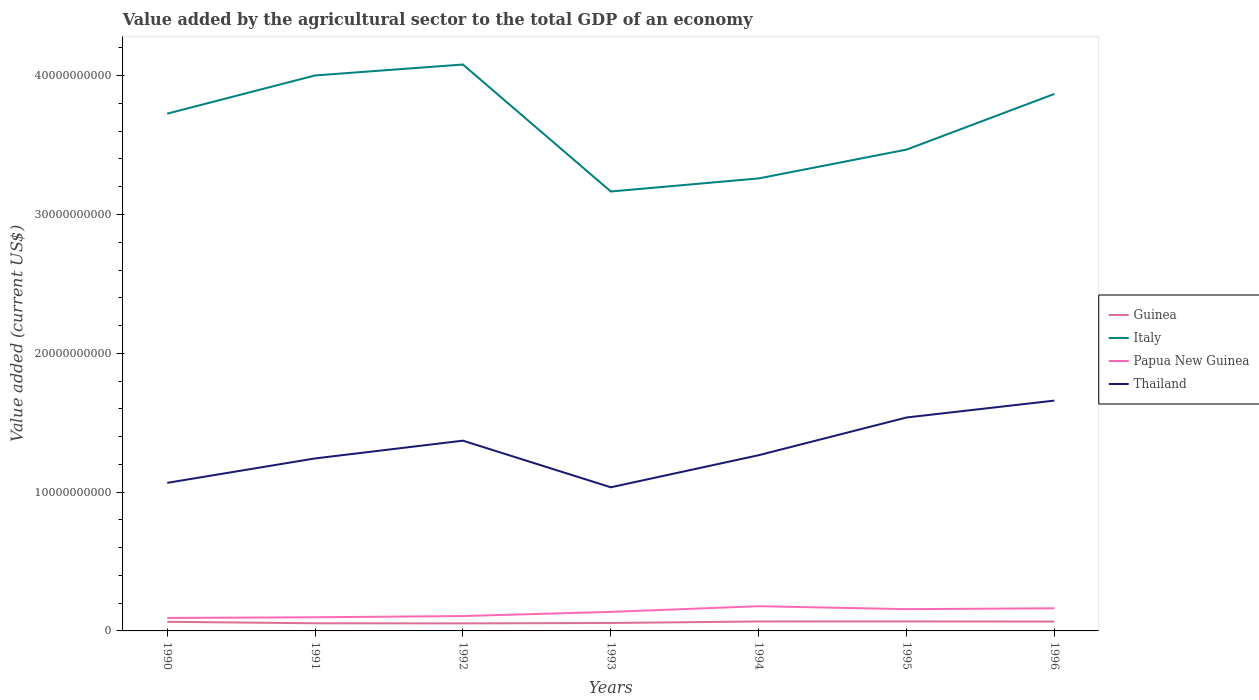How many different coloured lines are there?
Make the answer very short. 4. Does the line corresponding to Italy intersect with the line corresponding to Thailand?
Keep it short and to the point. No. Across all years, what is the maximum value added by the agricultural sector to the total GDP in Italy?
Your answer should be compact. 3.17e+1. In which year was the value added by the agricultural sector to the total GDP in Papua New Guinea maximum?
Your response must be concise. 1990. What is the total value added by the agricultural sector to the total GDP in Papua New Guinea in the graph?
Give a very brief answer. -2.60e+08. What is the difference between the highest and the second highest value added by the agricultural sector to the total GDP in Papua New Guinea?
Your response must be concise. 8.48e+08. Is the value added by the agricultural sector to the total GDP in Thailand strictly greater than the value added by the agricultural sector to the total GDP in Guinea over the years?
Ensure brevity in your answer.  No. How many lines are there?
Give a very brief answer. 4. How many years are there in the graph?
Your response must be concise. 7. What is the difference between two consecutive major ticks on the Y-axis?
Offer a terse response. 1.00e+1. Are the values on the major ticks of Y-axis written in scientific E-notation?
Keep it short and to the point. No. Where does the legend appear in the graph?
Make the answer very short. Center right. How many legend labels are there?
Make the answer very short. 4. What is the title of the graph?
Offer a very short reply. Value added by the agricultural sector to the total GDP of an economy. What is the label or title of the X-axis?
Offer a very short reply. Years. What is the label or title of the Y-axis?
Give a very brief answer. Value added (current US$). What is the Value added (current US$) of Guinea in 1990?
Offer a terse response. 6.58e+08. What is the Value added (current US$) in Italy in 1990?
Give a very brief answer. 3.73e+1. What is the Value added (current US$) of Papua New Guinea in 1990?
Provide a short and direct response. 9.33e+08. What is the Value added (current US$) in Thailand in 1990?
Provide a succinct answer. 1.07e+1. What is the Value added (current US$) of Guinea in 1991?
Provide a short and direct response. 5.51e+08. What is the Value added (current US$) in Italy in 1991?
Provide a succinct answer. 4.00e+1. What is the Value added (current US$) of Papua New Guinea in 1991?
Offer a very short reply. 9.84e+08. What is the Value added (current US$) of Thailand in 1991?
Your answer should be very brief. 1.24e+1. What is the Value added (current US$) in Guinea in 1992?
Provide a short and direct response. 5.44e+08. What is the Value added (current US$) in Italy in 1992?
Your answer should be compact. 4.08e+1. What is the Value added (current US$) of Papua New Guinea in 1992?
Your answer should be very brief. 1.07e+09. What is the Value added (current US$) in Thailand in 1992?
Offer a very short reply. 1.37e+1. What is the Value added (current US$) in Guinea in 1993?
Ensure brevity in your answer.  5.70e+08. What is the Value added (current US$) in Italy in 1993?
Provide a short and direct response. 3.17e+1. What is the Value added (current US$) in Papua New Guinea in 1993?
Give a very brief answer. 1.37e+09. What is the Value added (current US$) of Thailand in 1993?
Provide a short and direct response. 1.03e+1. What is the Value added (current US$) in Guinea in 1994?
Keep it short and to the point. 6.82e+08. What is the Value added (current US$) in Italy in 1994?
Offer a terse response. 3.26e+1. What is the Value added (current US$) in Papua New Guinea in 1994?
Your response must be concise. 1.78e+09. What is the Value added (current US$) in Thailand in 1994?
Keep it short and to the point. 1.27e+1. What is the Value added (current US$) in Guinea in 1995?
Provide a succinct answer. 6.84e+08. What is the Value added (current US$) in Italy in 1995?
Your response must be concise. 3.47e+1. What is the Value added (current US$) of Papua New Guinea in 1995?
Offer a terse response. 1.57e+09. What is the Value added (current US$) of Thailand in 1995?
Provide a succinct answer. 1.54e+1. What is the Value added (current US$) of Guinea in 1996?
Your answer should be very brief. 6.73e+08. What is the Value added (current US$) in Italy in 1996?
Make the answer very short. 3.87e+1. What is the Value added (current US$) in Papua New Guinea in 1996?
Your response must be concise. 1.63e+09. What is the Value added (current US$) in Thailand in 1996?
Make the answer very short. 1.66e+1. Across all years, what is the maximum Value added (current US$) in Guinea?
Provide a short and direct response. 6.84e+08. Across all years, what is the maximum Value added (current US$) in Italy?
Your answer should be compact. 4.08e+1. Across all years, what is the maximum Value added (current US$) of Papua New Guinea?
Make the answer very short. 1.78e+09. Across all years, what is the maximum Value added (current US$) in Thailand?
Provide a succinct answer. 1.66e+1. Across all years, what is the minimum Value added (current US$) in Guinea?
Offer a terse response. 5.44e+08. Across all years, what is the minimum Value added (current US$) of Italy?
Offer a terse response. 3.17e+1. Across all years, what is the minimum Value added (current US$) of Papua New Guinea?
Provide a succinct answer. 9.33e+08. Across all years, what is the minimum Value added (current US$) in Thailand?
Keep it short and to the point. 1.03e+1. What is the total Value added (current US$) of Guinea in the graph?
Make the answer very short. 4.36e+09. What is the total Value added (current US$) of Italy in the graph?
Your answer should be very brief. 2.56e+11. What is the total Value added (current US$) in Papua New Guinea in the graph?
Your answer should be compact. 9.34e+09. What is the total Value added (current US$) of Thailand in the graph?
Your answer should be compact. 9.18e+1. What is the difference between the Value added (current US$) in Guinea in 1990 and that in 1991?
Your response must be concise. 1.08e+08. What is the difference between the Value added (current US$) of Italy in 1990 and that in 1991?
Your answer should be compact. -2.75e+09. What is the difference between the Value added (current US$) in Papua New Guinea in 1990 and that in 1991?
Provide a succinct answer. -5.10e+07. What is the difference between the Value added (current US$) in Thailand in 1990 and that in 1991?
Your answer should be compact. -1.76e+09. What is the difference between the Value added (current US$) of Guinea in 1990 and that in 1992?
Your response must be concise. 1.15e+08. What is the difference between the Value added (current US$) of Italy in 1990 and that in 1992?
Give a very brief answer. -3.54e+09. What is the difference between the Value added (current US$) of Papua New Guinea in 1990 and that in 1992?
Keep it short and to the point. -1.39e+08. What is the difference between the Value added (current US$) of Thailand in 1990 and that in 1992?
Keep it short and to the point. -3.04e+09. What is the difference between the Value added (current US$) in Guinea in 1990 and that in 1993?
Your answer should be very brief. 8.80e+07. What is the difference between the Value added (current US$) in Italy in 1990 and that in 1993?
Your response must be concise. 5.61e+09. What is the difference between the Value added (current US$) of Papua New Guinea in 1990 and that in 1993?
Give a very brief answer. -4.38e+08. What is the difference between the Value added (current US$) of Thailand in 1990 and that in 1993?
Provide a succinct answer. 3.20e+08. What is the difference between the Value added (current US$) of Guinea in 1990 and that in 1994?
Make the answer very short. -2.40e+07. What is the difference between the Value added (current US$) of Italy in 1990 and that in 1994?
Ensure brevity in your answer.  4.67e+09. What is the difference between the Value added (current US$) in Papua New Guinea in 1990 and that in 1994?
Provide a succinct answer. -8.48e+08. What is the difference between the Value added (current US$) of Thailand in 1990 and that in 1994?
Offer a very short reply. -1.99e+09. What is the difference between the Value added (current US$) in Guinea in 1990 and that in 1995?
Provide a succinct answer. -2.57e+07. What is the difference between the Value added (current US$) in Italy in 1990 and that in 1995?
Your answer should be very brief. 2.59e+09. What is the difference between the Value added (current US$) in Papua New Guinea in 1990 and that in 1995?
Offer a very short reply. -6.35e+08. What is the difference between the Value added (current US$) of Thailand in 1990 and that in 1995?
Make the answer very short. -4.71e+09. What is the difference between the Value added (current US$) in Guinea in 1990 and that in 1996?
Give a very brief answer. -1.48e+07. What is the difference between the Value added (current US$) in Italy in 1990 and that in 1996?
Make the answer very short. -1.42e+09. What is the difference between the Value added (current US$) of Papua New Guinea in 1990 and that in 1996?
Your answer should be very brief. -6.99e+08. What is the difference between the Value added (current US$) in Thailand in 1990 and that in 1996?
Keep it short and to the point. -5.92e+09. What is the difference between the Value added (current US$) of Guinea in 1991 and that in 1992?
Offer a terse response. 6.75e+06. What is the difference between the Value added (current US$) in Italy in 1991 and that in 1992?
Provide a short and direct response. -7.87e+08. What is the difference between the Value added (current US$) in Papua New Guinea in 1991 and that in 1992?
Your response must be concise. -8.75e+07. What is the difference between the Value added (current US$) of Thailand in 1991 and that in 1992?
Your answer should be compact. -1.28e+09. What is the difference between the Value added (current US$) in Guinea in 1991 and that in 1993?
Offer a terse response. -1.98e+07. What is the difference between the Value added (current US$) of Italy in 1991 and that in 1993?
Give a very brief answer. 8.36e+09. What is the difference between the Value added (current US$) in Papua New Guinea in 1991 and that in 1993?
Your answer should be very brief. -3.87e+08. What is the difference between the Value added (current US$) in Thailand in 1991 and that in 1993?
Provide a succinct answer. 2.08e+09. What is the difference between the Value added (current US$) of Guinea in 1991 and that in 1994?
Your answer should be compact. -1.32e+08. What is the difference between the Value added (current US$) in Italy in 1991 and that in 1994?
Your answer should be compact. 7.42e+09. What is the difference between the Value added (current US$) of Papua New Guinea in 1991 and that in 1994?
Offer a terse response. -7.97e+08. What is the difference between the Value added (current US$) in Thailand in 1991 and that in 1994?
Offer a very short reply. -2.31e+08. What is the difference between the Value added (current US$) in Guinea in 1991 and that in 1995?
Give a very brief answer. -1.33e+08. What is the difference between the Value added (current US$) in Italy in 1991 and that in 1995?
Your answer should be compact. 5.34e+09. What is the difference between the Value added (current US$) in Papua New Guinea in 1991 and that in 1995?
Offer a very short reply. -5.84e+08. What is the difference between the Value added (current US$) in Thailand in 1991 and that in 1995?
Ensure brevity in your answer.  -2.95e+09. What is the difference between the Value added (current US$) of Guinea in 1991 and that in 1996?
Provide a succinct answer. -1.23e+08. What is the difference between the Value added (current US$) in Italy in 1991 and that in 1996?
Provide a short and direct response. 1.33e+09. What is the difference between the Value added (current US$) of Papua New Guinea in 1991 and that in 1996?
Give a very brief answer. -6.48e+08. What is the difference between the Value added (current US$) in Thailand in 1991 and that in 1996?
Ensure brevity in your answer.  -4.17e+09. What is the difference between the Value added (current US$) of Guinea in 1992 and that in 1993?
Ensure brevity in your answer.  -2.66e+07. What is the difference between the Value added (current US$) in Italy in 1992 and that in 1993?
Make the answer very short. 9.15e+09. What is the difference between the Value added (current US$) of Papua New Guinea in 1992 and that in 1993?
Provide a succinct answer. -3.00e+08. What is the difference between the Value added (current US$) in Thailand in 1992 and that in 1993?
Offer a very short reply. 3.36e+09. What is the difference between the Value added (current US$) in Guinea in 1992 and that in 1994?
Your response must be concise. -1.39e+08. What is the difference between the Value added (current US$) of Italy in 1992 and that in 1994?
Ensure brevity in your answer.  8.21e+09. What is the difference between the Value added (current US$) in Papua New Guinea in 1992 and that in 1994?
Your answer should be very brief. -7.09e+08. What is the difference between the Value added (current US$) of Thailand in 1992 and that in 1994?
Offer a terse response. 1.05e+09. What is the difference between the Value added (current US$) of Guinea in 1992 and that in 1995?
Give a very brief answer. -1.40e+08. What is the difference between the Value added (current US$) in Italy in 1992 and that in 1995?
Provide a succinct answer. 6.13e+09. What is the difference between the Value added (current US$) of Papua New Guinea in 1992 and that in 1995?
Ensure brevity in your answer.  -4.96e+08. What is the difference between the Value added (current US$) in Thailand in 1992 and that in 1995?
Give a very brief answer. -1.67e+09. What is the difference between the Value added (current US$) of Guinea in 1992 and that in 1996?
Offer a terse response. -1.29e+08. What is the difference between the Value added (current US$) in Italy in 1992 and that in 1996?
Offer a very short reply. 2.12e+09. What is the difference between the Value added (current US$) of Papua New Guinea in 1992 and that in 1996?
Offer a terse response. -5.60e+08. What is the difference between the Value added (current US$) in Thailand in 1992 and that in 1996?
Give a very brief answer. -2.89e+09. What is the difference between the Value added (current US$) in Guinea in 1993 and that in 1994?
Keep it short and to the point. -1.12e+08. What is the difference between the Value added (current US$) in Italy in 1993 and that in 1994?
Offer a very short reply. -9.42e+08. What is the difference between the Value added (current US$) in Papua New Guinea in 1993 and that in 1994?
Give a very brief answer. -4.09e+08. What is the difference between the Value added (current US$) in Thailand in 1993 and that in 1994?
Ensure brevity in your answer.  -2.31e+09. What is the difference between the Value added (current US$) in Guinea in 1993 and that in 1995?
Offer a terse response. -1.14e+08. What is the difference between the Value added (current US$) of Italy in 1993 and that in 1995?
Give a very brief answer. -3.02e+09. What is the difference between the Value added (current US$) of Papua New Guinea in 1993 and that in 1995?
Make the answer very short. -1.96e+08. What is the difference between the Value added (current US$) in Thailand in 1993 and that in 1995?
Give a very brief answer. -5.03e+09. What is the difference between the Value added (current US$) of Guinea in 1993 and that in 1996?
Your answer should be very brief. -1.03e+08. What is the difference between the Value added (current US$) of Italy in 1993 and that in 1996?
Your response must be concise. -7.03e+09. What is the difference between the Value added (current US$) in Papua New Guinea in 1993 and that in 1996?
Your answer should be compact. -2.60e+08. What is the difference between the Value added (current US$) of Thailand in 1993 and that in 1996?
Keep it short and to the point. -6.25e+09. What is the difference between the Value added (current US$) in Guinea in 1994 and that in 1995?
Ensure brevity in your answer.  -1.69e+06. What is the difference between the Value added (current US$) of Italy in 1994 and that in 1995?
Ensure brevity in your answer.  -2.08e+09. What is the difference between the Value added (current US$) of Papua New Guinea in 1994 and that in 1995?
Give a very brief answer. 2.13e+08. What is the difference between the Value added (current US$) of Thailand in 1994 and that in 1995?
Offer a very short reply. -2.72e+09. What is the difference between the Value added (current US$) of Guinea in 1994 and that in 1996?
Your answer should be very brief. 9.15e+06. What is the difference between the Value added (current US$) in Italy in 1994 and that in 1996?
Offer a terse response. -6.09e+09. What is the difference between the Value added (current US$) of Papua New Guinea in 1994 and that in 1996?
Provide a succinct answer. 1.49e+08. What is the difference between the Value added (current US$) of Thailand in 1994 and that in 1996?
Your answer should be compact. -3.93e+09. What is the difference between the Value added (current US$) of Guinea in 1995 and that in 1996?
Offer a terse response. 1.08e+07. What is the difference between the Value added (current US$) of Italy in 1995 and that in 1996?
Offer a terse response. -4.01e+09. What is the difference between the Value added (current US$) in Papua New Guinea in 1995 and that in 1996?
Your response must be concise. -6.39e+07. What is the difference between the Value added (current US$) in Thailand in 1995 and that in 1996?
Offer a very short reply. -1.22e+09. What is the difference between the Value added (current US$) of Guinea in 1990 and the Value added (current US$) of Italy in 1991?
Your answer should be compact. -3.94e+1. What is the difference between the Value added (current US$) in Guinea in 1990 and the Value added (current US$) in Papua New Guinea in 1991?
Give a very brief answer. -3.26e+08. What is the difference between the Value added (current US$) of Guinea in 1990 and the Value added (current US$) of Thailand in 1991?
Provide a succinct answer. -1.18e+1. What is the difference between the Value added (current US$) in Italy in 1990 and the Value added (current US$) in Papua New Guinea in 1991?
Give a very brief answer. 3.63e+1. What is the difference between the Value added (current US$) in Italy in 1990 and the Value added (current US$) in Thailand in 1991?
Your answer should be very brief. 2.48e+1. What is the difference between the Value added (current US$) in Papua New Guinea in 1990 and the Value added (current US$) in Thailand in 1991?
Give a very brief answer. -1.15e+1. What is the difference between the Value added (current US$) in Guinea in 1990 and the Value added (current US$) in Italy in 1992?
Ensure brevity in your answer.  -4.01e+1. What is the difference between the Value added (current US$) of Guinea in 1990 and the Value added (current US$) of Papua New Guinea in 1992?
Your response must be concise. -4.13e+08. What is the difference between the Value added (current US$) of Guinea in 1990 and the Value added (current US$) of Thailand in 1992?
Provide a short and direct response. -1.30e+1. What is the difference between the Value added (current US$) in Italy in 1990 and the Value added (current US$) in Papua New Guinea in 1992?
Provide a short and direct response. 3.62e+1. What is the difference between the Value added (current US$) in Italy in 1990 and the Value added (current US$) in Thailand in 1992?
Give a very brief answer. 2.36e+1. What is the difference between the Value added (current US$) in Papua New Guinea in 1990 and the Value added (current US$) in Thailand in 1992?
Your answer should be very brief. -1.28e+1. What is the difference between the Value added (current US$) in Guinea in 1990 and the Value added (current US$) in Italy in 1993?
Keep it short and to the point. -3.10e+1. What is the difference between the Value added (current US$) in Guinea in 1990 and the Value added (current US$) in Papua New Guinea in 1993?
Your answer should be very brief. -7.13e+08. What is the difference between the Value added (current US$) of Guinea in 1990 and the Value added (current US$) of Thailand in 1993?
Your response must be concise. -9.69e+09. What is the difference between the Value added (current US$) of Italy in 1990 and the Value added (current US$) of Papua New Guinea in 1993?
Give a very brief answer. 3.59e+1. What is the difference between the Value added (current US$) of Italy in 1990 and the Value added (current US$) of Thailand in 1993?
Your answer should be compact. 2.69e+1. What is the difference between the Value added (current US$) in Papua New Guinea in 1990 and the Value added (current US$) in Thailand in 1993?
Offer a very short reply. -9.41e+09. What is the difference between the Value added (current US$) of Guinea in 1990 and the Value added (current US$) of Italy in 1994?
Your answer should be compact. -3.19e+1. What is the difference between the Value added (current US$) of Guinea in 1990 and the Value added (current US$) of Papua New Guinea in 1994?
Provide a succinct answer. -1.12e+09. What is the difference between the Value added (current US$) of Guinea in 1990 and the Value added (current US$) of Thailand in 1994?
Provide a succinct answer. -1.20e+1. What is the difference between the Value added (current US$) of Italy in 1990 and the Value added (current US$) of Papua New Guinea in 1994?
Your response must be concise. 3.55e+1. What is the difference between the Value added (current US$) in Italy in 1990 and the Value added (current US$) in Thailand in 1994?
Your response must be concise. 2.46e+1. What is the difference between the Value added (current US$) of Papua New Guinea in 1990 and the Value added (current US$) of Thailand in 1994?
Offer a very short reply. -1.17e+1. What is the difference between the Value added (current US$) in Guinea in 1990 and the Value added (current US$) in Italy in 1995?
Give a very brief answer. -3.40e+1. What is the difference between the Value added (current US$) in Guinea in 1990 and the Value added (current US$) in Papua New Guinea in 1995?
Give a very brief answer. -9.09e+08. What is the difference between the Value added (current US$) in Guinea in 1990 and the Value added (current US$) in Thailand in 1995?
Make the answer very short. -1.47e+1. What is the difference between the Value added (current US$) of Italy in 1990 and the Value added (current US$) of Papua New Guinea in 1995?
Offer a very short reply. 3.57e+1. What is the difference between the Value added (current US$) in Italy in 1990 and the Value added (current US$) in Thailand in 1995?
Your answer should be very brief. 2.19e+1. What is the difference between the Value added (current US$) in Papua New Guinea in 1990 and the Value added (current US$) in Thailand in 1995?
Make the answer very short. -1.44e+1. What is the difference between the Value added (current US$) in Guinea in 1990 and the Value added (current US$) in Italy in 1996?
Your answer should be very brief. -3.80e+1. What is the difference between the Value added (current US$) of Guinea in 1990 and the Value added (current US$) of Papua New Guinea in 1996?
Provide a short and direct response. -9.73e+08. What is the difference between the Value added (current US$) in Guinea in 1990 and the Value added (current US$) in Thailand in 1996?
Provide a succinct answer. -1.59e+1. What is the difference between the Value added (current US$) in Italy in 1990 and the Value added (current US$) in Papua New Guinea in 1996?
Your answer should be compact. 3.56e+1. What is the difference between the Value added (current US$) in Italy in 1990 and the Value added (current US$) in Thailand in 1996?
Make the answer very short. 2.07e+1. What is the difference between the Value added (current US$) of Papua New Guinea in 1990 and the Value added (current US$) of Thailand in 1996?
Offer a terse response. -1.57e+1. What is the difference between the Value added (current US$) in Guinea in 1991 and the Value added (current US$) in Italy in 1992?
Provide a succinct answer. -4.03e+1. What is the difference between the Value added (current US$) in Guinea in 1991 and the Value added (current US$) in Papua New Guinea in 1992?
Offer a terse response. -5.21e+08. What is the difference between the Value added (current US$) of Guinea in 1991 and the Value added (current US$) of Thailand in 1992?
Ensure brevity in your answer.  -1.32e+1. What is the difference between the Value added (current US$) in Italy in 1991 and the Value added (current US$) in Papua New Guinea in 1992?
Offer a terse response. 3.89e+1. What is the difference between the Value added (current US$) in Italy in 1991 and the Value added (current US$) in Thailand in 1992?
Your answer should be compact. 2.63e+1. What is the difference between the Value added (current US$) of Papua New Guinea in 1991 and the Value added (current US$) of Thailand in 1992?
Keep it short and to the point. -1.27e+1. What is the difference between the Value added (current US$) in Guinea in 1991 and the Value added (current US$) in Italy in 1993?
Offer a terse response. -3.11e+1. What is the difference between the Value added (current US$) of Guinea in 1991 and the Value added (current US$) of Papua New Guinea in 1993?
Your response must be concise. -8.21e+08. What is the difference between the Value added (current US$) of Guinea in 1991 and the Value added (current US$) of Thailand in 1993?
Keep it short and to the point. -9.80e+09. What is the difference between the Value added (current US$) of Italy in 1991 and the Value added (current US$) of Papua New Guinea in 1993?
Keep it short and to the point. 3.86e+1. What is the difference between the Value added (current US$) in Italy in 1991 and the Value added (current US$) in Thailand in 1993?
Your answer should be very brief. 2.97e+1. What is the difference between the Value added (current US$) in Papua New Guinea in 1991 and the Value added (current US$) in Thailand in 1993?
Keep it short and to the point. -9.36e+09. What is the difference between the Value added (current US$) in Guinea in 1991 and the Value added (current US$) in Italy in 1994?
Offer a terse response. -3.20e+1. What is the difference between the Value added (current US$) of Guinea in 1991 and the Value added (current US$) of Papua New Guinea in 1994?
Ensure brevity in your answer.  -1.23e+09. What is the difference between the Value added (current US$) of Guinea in 1991 and the Value added (current US$) of Thailand in 1994?
Provide a succinct answer. -1.21e+1. What is the difference between the Value added (current US$) of Italy in 1991 and the Value added (current US$) of Papua New Guinea in 1994?
Give a very brief answer. 3.82e+1. What is the difference between the Value added (current US$) of Italy in 1991 and the Value added (current US$) of Thailand in 1994?
Ensure brevity in your answer.  2.74e+1. What is the difference between the Value added (current US$) in Papua New Guinea in 1991 and the Value added (current US$) in Thailand in 1994?
Ensure brevity in your answer.  -1.17e+1. What is the difference between the Value added (current US$) in Guinea in 1991 and the Value added (current US$) in Italy in 1995?
Provide a succinct answer. -3.41e+1. What is the difference between the Value added (current US$) of Guinea in 1991 and the Value added (current US$) of Papua New Guinea in 1995?
Offer a very short reply. -1.02e+09. What is the difference between the Value added (current US$) in Guinea in 1991 and the Value added (current US$) in Thailand in 1995?
Your answer should be compact. -1.48e+1. What is the difference between the Value added (current US$) in Italy in 1991 and the Value added (current US$) in Papua New Guinea in 1995?
Provide a short and direct response. 3.84e+1. What is the difference between the Value added (current US$) in Italy in 1991 and the Value added (current US$) in Thailand in 1995?
Provide a short and direct response. 2.46e+1. What is the difference between the Value added (current US$) of Papua New Guinea in 1991 and the Value added (current US$) of Thailand in 1995?
Provide a short and direct response. -1.44e+1. What is the difference between the Value added (current US$) of Guinea in 1991 and the Value added (current US$) of Italy in 1996?
Ensure brevity in your answer.  -3.81e+1. What is the difference between the Value added (current US$) in Guinea in 1991 and the Value added (current US$) in Papua New Guinea in 1996?
Your answer should be very brief. -1.08e+09. What is the difference between the Value added (current US$) in Guinea in 1991 and the Value added (current US$) in Thailand in 1996?
Provide a short and direct response. -1.60e+1. What is the difference between the Value added (current US$) of Italy in 1991 and the Value added (current US$) of Papua New Guinea in 1996?
Offer a very short reply. 3.84e+1. What is the difference between the Value added (current US$) in Italy in 1991 and the Value added (current US$) in Thailand in 1996?
Offer a very short reply. 2.34e+1. What is the difference between the Value added (current US$) of Papua New Guinea in 1991 and the Value added (current US$) of Thailand in 1996?
Your response must be concise. -1.56e+1. What is the difference between the Value added (current US$) in Guinea in 1992 and the Value added (current US$) in Italy in 1993?
Offer a terse response. -3.11e+1. What is the difference between the Value added (current US$) in Guinea in 1992 and the Value added (current US$) in Papua New Guinea in 1993?
Make the answer very short. -8.28e+08. What is the difference between the Value added (current US$) of Guinea in 1992 and the Value added (current US$) of Thailand in 1993?
Ensure brevity in your answer.  -9.80e+09. What is the difference between the Value added (current US$) in Italy in 1992 and the Value added (current US$) in Papua New Guinea in 1993?
Provide a short and direct response. 3.94e+1. What is the difference between the Value added (current US$) in Italy in 1992 and the Value added (current US$) in Thailand in 1993?
Provide a short and direct response. 3.05e+1. What is the difference between the Value added (current US$) in Papua New Guinea in 1992 and the Value added (current US$) in Thailand in 1993?
Your answer should be compact. -9.28e+09. What is the difference between the Value added (current US$) of Guinea in 1992 and the Value added (current US$) of Italy in 1994?
Give a very brief answer. -3.21e+1. What is the difference between the Value added (current US$) of Guinea in 1992 and the Value added (current US$) of Papua New Guinea in 1994?
Offer a very short reply. -1.24e+09. What is the difference between the Value added (current US$) in Guinea in 1992 and the Value added (current US$) in Thailand in 1994?
Make the answer very short. -1.21e+1. What is the difference between the Value added (current US$) of Italy in 1992 and the Value added (current US$) of Papua New Guinea in 1994?
Your response must be concise. 3.90e+1. What is the difference between the Value added (current US$) of Italy in 1992 and the Value added (current US$) of Thailand in 1994?
Your response must be concise. 2.81e+1. What is the difference between the Value added (current US$) in Papua New Guinea in 1992 and the Value added (current US$) in Thailand in 1994?
Your answer should be very brief. -1.16e+1. What is the difference between the Value added (current US$) in Guinea in 1992 and the Value added (current US$) in Italy in 1995?
Your response must be concise. -3.41e+1. What is the difference between the Value added (current US$) of Guinea in 1992 and the Value added (current US$) of Papua New Guinea in 1995?
Give a very brief answer. -1.02e+09. What is the difference between the Value added (current US$) in Guinea in 1992 and the Value added (current US$) in Thailand in 1995?
Provide a short and direct response. -1.48e+1. What is the difference between the Value added (current US$) of Italy in 1992 and the Value added (current US$) of Papua New Guinea in 1995?
Ensure brevity in your answer.  3.92e+1. What is the difference between the Value added (current US$) of Italy in 1992 and the Value added (current US$) of Thailand in 1995?
Your response must be concise. 2.54e+1. What is the difference between the Value added (current US$) of Papua New Guinea in 1992 and the Value added (current US$) of Thailand in 1995?
Your answer should be very brief. -1.43e+1. What is the difference between the Value added (current US$) of Guinea in 1992 and the Value added (current US$) of Italy in 1996?
Ensure brevity in your answer.  -3.81e+1. What is the difference between the Value added (current US$) in Guinea in 1992 and the Value added (current US$) in Papua New Guinea in 1996?
Your response must be concise. -1.09e+09. What is the difference between the Value added (current US$) of Guinea in 1992 and the Value added (current US$) of Thailand in 1996?
Your answer should be very brief. -1.60e+1. What is the difference between the Value added (current US$) in Italy in 1992 and the Value added (current US$) in Papua New Guinea in 1996?
Your response must be concise. 3.92e+1. What is the difference between the Value added (current US$) in Italy in 1992 and the Value added (current US$) in Thailand in 1996?
Make the answer very short. 2.42e+1. What is the difference between the Value added (current US$) of Papua New Guinea in 1992 and the Value added (current US$) of Thailand in 1996?
Provide a short and direct response. -1.55e+1. What is the difference between the Value added (current US$) in Guinea in 1993 and the Value added (current US$) in Italy in 1994?
Make the answer very short. -3.20e+1. What is the difference between the Value added (current US$) of Guinea in 1993 and the Value added (current US$) of Papua New Guinea in 1994?
Make the answer very short. -1.21e+09. What is the difference between the Value added (current US$) in Guinea in 1993 and the Value added (current US$) in Thailand in 1994?
Provide a succinct answer. -1.21e+1. What is the difference between the Value added (current US$) of Italy in 1993 and the Value added (current US$) of Papua New Guinea in 1994?
Offer a very short reply. 2.99e+1. What is the difference between the Value added (current US$) of Italy in 1993 and the Value added (current US$) of Thailand in 1994?
Your answer should be very brief. 1.90e+1. What is the difference between the Value added (current US$) of Papua New Guinea in 1993 and the Value added (current US$) of Thailand in 1994?
Keep it short and to the point. -1.13e+1. What is the difference between the Value added (current US$) in Guinea in 1993 and the Value added (current US$) in Italy in 1995?
Your answer should be compact. -3.41e+1. What is the difference between the Value added (current US$) of Guinea in 1993 and the Value added (current US$) of Papua New Guinea in 1995?
Offer a terse response. -9.97e+08. What is the difference between the Value added (current US$) in Guinea in 1993 and the Value added (current US$) in Thailand in 1995?
Your answer should be very brief. -1.48e+1. What is the difference between the Value added (current US$) of Italy in 1993 and the Value added (current US$) of Papua New Guinea in 1995?
Your answer should be compact. 3.01e+1. What is the difference between the Value added (current US$) of Italy in 1993 and the Value added (current US$) of Thailand in 1995?
Provide a succinct answer. 1.63e+1. What is the difference between the Value added (current US$) in Papua New Guinea in 1993 and the Value added (current US$) in Thailand in 1995?
Offer a terse response. -1.40e+1. What is the difference between the Value added (current US$) in Guinea in 1993 and the Value added (current US$) in Italy in 1996?
Provide a short and direct response. -3.81e+1. What is the difference between the Value added (current US$) in Guinea in 1993 and the Value added (current US$) in Papua New Guinea in 1996?
Offer a very short reply. -1.06e+09. What is the difference between the Value added (current US$) in Guinea in 1993 and the Value added (current US$) in Thailand in 1996?
Your response must be concise. -1.60e+1. What is the difference between the Value added (current US$) in Italy in 1993 and the Value added (current US$) in Papua New Guinea in 1996?
Your response must be concise. 3.00e+1. What is the difference between the Value added (current US$) of Italy in 1993 and the Value added (current US$) of Thailand in 1996?
Offer a very short reply. 1.51e+1. What is the difference between the Value added (current US$) of Papua New Guinea in 1993 and the Value added (current US$) of Thailand in 1996?
Provide a succinct answer. -1.52e+1. What is the difference between the Value added (current US$) of Guinea in 1994 and the Value added (current US$) of Italy in 1995?
Your response must be concise. -3.40e+1. What is the difference between the Value added (current US$) of Guinea in 1994 and the Value added (current US$) of Papua New Guinea in 1995?
Offer a very short reply. -8.85e+08. What is the difference between the Value added (current US$) in Guinea in 1994 and the Value added (current US$) in Thailand in 1995?
Give a very brief answer. -1.47e+1. What is the difference between the Value added (current US$) of Italy in 1994 and the Value added (current US$) of Papua New Guinea in 1995?
Your answer should be compact. 3.10e+1. What is the difference between the Value added (current US$) in Italy in 1994 and the Value added (current US$) in Thailand in 1995?
Make the answer very short. 1.72e+1. What is the difference between the Value added (current US$) of Papua New Guinea in 1994 and the Value added (current US$) of Thailand in 1995?
Provide a succinct answer. -1.36e+1. What is the difference between the Value added (current US$) in Guinea in 1994 and the Value added (current US$) in Italy in 1996?
Offer a terse response. -3.80e+1. What is the difference between the Value added (current US$) in Guinea in 1994 and the Value added (current US$) in Papua New Guinea in 1996?
Make the answer very short. -9.49e+08. What is the difference between the Value added (current US$) of Guinea in 1994 and the Value added (current US$) of Thailand in 1996?
Make the answer very short. -1.59e+1. What is the difference between the Value added (current US$) of Italy in 1994 and the Value added (current US$) of Papua New Guinea in 1996?
Offer a terse response. 3.10e+1. What is the difference between the Value added (current US$) of Italy in 1994 and the Value added (current US$) of Thailand in 1996?
Keep it short and to the point. 1.60e+1. What is the difference between the Value added (current US$) of Papua New Guinea in 1994 and the Value added (current US$) of Thailand in 1996?
Offer a very short reply. -1.48e+1. What is the difference between the Value added (current US$) of Guinea in 1995 and the Value added (current US$) of Italy in 1996?
Keep it short and to the point. -3.80e+1. What is the difference between the Value added (current US$) in Guinea in 1995 and the Value added (current US$) in Papua New Guinea in 1996?
Ensure brevity in your answer.  -9.47e+08. What is the difference between the Value added (current US$) in Guinea in 1995 and the Value added (current US$) in Thailand in 1996?
Provide a succinct answer. -1.59e+1. What is the difference between the Value added (current US$) of Italy in 1995 and the Value added (current US$) of Papua New Guinea in 1996?
Offer a terse response. 3.30e+1. What is the difference between the Value added (current US$) of Italy in 1995 and the Value added (current US$) of Thailand in 1996?
Your answer should be very brief. 1.81e+1. What is the difference between the Value added (current US$) in Papua New Guinea in 1995 and the Value added (current US$) in Thailand in 1996?
Your answer should be compact. -1.50e+1. What is the average Value added (current US$) in Guinea per year?
Provide a short and direct response. 6.23e+08. What is the average Value added (current US$) in Italy per year?
Ensure brevity in your answer.  3.65e+1. What is the average Value added (current US$) of Papua New Guinea per year?
Make the answer very short. 1.33e+09. What is the average Value added (current US$) in Thailand per year?
Your response must be concise. 1.31e+1. In the year 1990, what is the difference between the Value added (current US$) of Guinea and Value added (current US$) of Italy?
Keep it short and to the point. -3.66e+1. In the year 1990, what is the difference between the Value added (current US$) in Guinea and Value added (current US$) in Papua New Guinea?
Make the answer very short. -2.75e+08. In the year 1990, what is the difference between the Value added (current US$) in Guinea and Value added (current US$) in Thailand?
Offer a terse response. -1.00e+1. In the year 1990, what is the difference between the Value added (current US$) of Italy and Value added (current US$) of Papua New Guinea?
Your answer should be very brief. 3.63e+1. In the year 1990, what is the difference between the Value added (current US$) in Italy and Value added (current US$) in Thailand?
Offer a terse response. 2.66e+1. In the year 1990, what is the difference between the Value added (current US$) of Papua New Guinea and Value added (current US$) of Thailand?
Your answer should be compact. -9.73e+09. In the year 1991, what is the difference between the Value added (current US$) of Guinea and Value added (current US$) of Italy?
Give a very brief answer. -3.95e+1. In the year 1991, what is the difference between the Value added (current US$) in Guinea and Value added (current US$) in Papua New Guinea?
Keep it short and to the point. -4.33e+08. In the year 1991, what is the difference between the Value added (current US$) in Guinea and Value added (current US$) in Thailand?
Your response must be concise. -1.19e+1. In the year 1991, what is the difference between the Value added (current US$) in Italy and Value added (current US$) in Papua New Guinea?
Provide a succinct answer. 3.90e+1. In the year 1991, what is the difference between the Value added (current US$) in Italy and Value added (current US$) in Thailand?
Give a very brief answer. 2.76e+1. In the year 1991, what is the difference between the Value added (current US$) of Papua New Guinea and Value added (current US$) of Thailand?
Your response must be concise. -1.14e+1. In the year 1992, what is the difference between the Value added (current US$) in Guinea and Value added (current US$) in Italy?
Make the answer very short. -4.03e+1. In the year 1992, what is the difference between the Value added (current US$) of Guinea and Value added (current US$) of Papua New Guinea?
Provide a succinct answer. -5.28e+08. In the year 1992, what is the difference between the Value added (current US$) of Guinea and Value added (current US$) of Thailand?
Keep it short and to the point. -1.32e+1. In the year 1992, what is the difference between the Value added (current US$) of Italy and Value added (current US$) of Papua New Guinea?
Make the answer very short. 3.97e+1. In the year 1992, what is the difference between the Value added (current US$) of Italy and Value added (current US$) of Thailand?
Provide a succinct answer. 2.71e+1. In the year 1992, what is the difference between the Value added (current US$) in Papua New Guinea and Value added (current US$) in Thailand?
Give a very brief answer. -1.26e+1. In the year 1993, what is the difference between the Value added (current US$) of Guinea and Value added (current US$) of Italy?
Make the answer very short. -3.11e+1. In the year 1993, what is the difference between the Value added (current US$) in Guinea and Value added (current US$) in Papua New Guinea?
Offer a very short reply. -8.01e+08. In the year 1993, what is the difference between the Value added (current US$) in Guinea and Value added (current US$) in Thailand?
Provide a short and direct response. -9.78e+09. In the year 1993, what is the difference between the Value added (current US$) in Italy and Value added (current US$) in Papua New Guinea?
Provide a short and direct response. 3.03e+1. In the year 1993, what is the difference between the Value added (current US$) of Italy and Value added (current US$) of Thailand?
Your answer should be very brief. 2.13e+1. In the year 1993, what is the difference between the Value added (current US$) of Papua New Guinea and Value added (current US$) of Thailand?
Provide a short and direct response. -8.98e+09. In the year 1994, what is the difference between the Value added (current US$) in Guinea and Value added (current US$) in Italy?
Offer a terse response. -3.19e+1. In the year 1994, what is the difference between the Value added (current US$) of Guinea and Value added (current US$) of Papua New Guinea?
Your answer should be compact. -1.10e+09. In the year 1994, what is the difference between the Value added (current US$) in Guinea and Value added (current US$) in Thailand?
Offer a very short reply. -1.20e+1. In the year 1994, what is the difference between the Value added (current US$) of Italy and Value added (current US$) of Papua New Guinea?
Ensure brevity in your answer.  3.08e+1. In the year 1994, what is the difference between the Value added (current US$) in Italy and Value added (current US$) in Thailand?
Your response must be concise. 1.99e+1. In the year 1994, what is the difference between the Value added (current US$) of Papua New Guinea and Value added (current US$) of Thailand?
Offer a very short reply. -1.09e+1. In the year 1995, what is the difference between the Value added (current US$) of Guinea and Value added (current US$) of Italy?
Your answer should be compact. -3.40e+1. In the year 1995, what is the difference between the Value added (current US$) in Guinea and Value added (current US$) in Papua New Guinea?
Make the answer very short. -8.84e+08. In the year 1995, what is the difference between the Value added (current US$) of Guinea and Value added (current US$) of Thailand?
Keep it short and to the point. -1.47e+1. In the year 1995, what is the difference between the Value added (current US$) in Italy and Value added (current US$) in Papua New Guinea?
Provide a short and direct response. 3.31e+1. In the year 1995, what is the difference between the Value added (current US$) in Italy and Value added (current US$) in Thailand?
Your answer should be compact. 1.93e+1. In the year 1995, what is the difference between the Value added (current US$) in Papua New Guinea and Value added (current US$) in Thailand?
Give a very brief answer. -1.38e+1. In the year 1996, what is the difference between the Value added (current US$) of Guinea and Value added (current US$) of Italy?
Offer a terse response. -3.80e+1. In the year 1996, what is the difference between the Value added (current US$) of Guinea and Value added (current US$) of Papua New Guinea?
Give a very brief answer. -9.58e+08. In the year 1996, what is the difference between the Value added (current US$) in Guinea and Value added (current US$) in Thailand?
Offer a terse response. -1.59e+1. In the year 1996, what is the difference between the Value added (current US$) of Italy and Value added (current US$) of Papua New Guinea?
Your answer should be compact. 3.71e+1. In the year 1996, what is the difference between the Value added (current US$) in Italy and Value added (current US$) in Thailand?
Keep it short and to the point. 2.21e+1. In the year 1996, what is the difference between the Value added (current US$) of Papua New Guinea and Value added (current US$) of Thailand?
Make the answer very short. -1.50e+1. What is the ratio of the Value added (current US$) in Guinea in 1990 to that in 1991?
Provide a short and direct response. 1.2. What is the ratio of the Value added (current US$) in Italy in 1990 to that in 1991?
Your answer should be very brief. 0.93. What is the ratio of the Value added (current US$) of Papua New Guinea in 1990 to that in 1991?
Offer a very short reply. 0.95. What is the ratio of the Value added (current US$) in Thailand in 1990 to that in 1991?
Give a very brief answer. 0.86. What is the ratio of the Value added (current US$) in Guinea in 1990 to that in 1992?
Ensure brevity in your answer.  1.21. What is the ratio of the Value added (current US$) in Italy in 1990 to that in 1992?
Provide a succinct answer. 0.91. What is the ratio of the Value added (current US$) of Papua New Guinea in 1990 to that in 1992?
Ensure brevity in your answer.  0.87. What is the ratio of the Value added (current US$) of Thailand in 1990 to that in 1992?
Give a very brief answer. 0.78. What is the ratio of the Value added (current US$) of Guinea in 1990 to that in 1993?
Provide a succinct answer. 1.15. What is the ratio of the Value added (current US$) in Italy in 1990 to that in 1993?
Your answer should be compact. 1.18. What is the ratio of the Value added (current US$) of Papua New Guinea in 1990 to that in 1993?
Your response must be concise. 0.68. What is the ratio of the Value added (current US$) in Thailand in 1990 to that in 1993?
Ensure brevity in your answer.  1.03. What is the ratio of the Value added (current US$) of Guinea in 1990 to that in 1994?
Offer a terse response. 0.96. What is the ratio of the Value added (current US$) in Italy in 1990 to that in 1994?
Your answer should be very brief. 1.14. What is the ratio of the Value added (current US$) in Papua New Guinea in 1990 to that in 1994?
Provide a succinct answer. 0.52. What is the ratio of the Value added (current US$) in Thailand in 1990 to that in 1994?
Keep it short and to the point. 0.84. What is the ratio of the Value added (current US$) in Guinea in 1990 to that in 1995?
Offer a terse response. 0.96. What is the ratio of the Value added (current US$) of Italy in 1990 to that in 1995?
Your answer should be very brief. 1.07. What is the ratio of the Value added (current US$) of Papua New Guinea in 1990 to that in 1995?
Your answer should be very brief. 0.6. What is the ratio of the Value added (current US$) of Thailand in 1990 to that in 1995?
Give a very brief answer. 0.69. What is the ratio of the Value added (current US$) of Guinea in 1990 to that in 1996?
Ensure brevity in your answer.  0.98. What is the ratio of the Value added (current US$) in Italy in 1990 to that in 1996?
Your answer should be compact. 0.96. What is the ratio of the Value added (current US$) in Papua New Guinea in 1990 to that in 1996?
Give a very brief answer. 0.57. What is the ratio of the Value added (current US$) of Thailand in 1990 to that in 1996?
Keep it short and to the point. 0.64. What is the ratio of the Value added (current US$) of Guinea in 1991 to that in 1992?
Your answer should be compact. 1.01. What is the ratio of the Value added (current US$) of Italy in 1991 to that in 1992?
Provide a short and direct response. 0.98. What is the ratio of the Value added (current US$) in Papua New Guinea in 1991 to that in 1992?
Ensure brevity in your answer.  0.92. What is the ratio of the Value added (current US$) of Thailand in 1991 to that in 1992?
Offer a terse response. 0.91. What is the ratio of the Value added (current US$) in Guinea in 1991 to that in 1993?
Provide a succinct answer. 0.97. What is the ratio of the Value added (current US$) of Italy in 1991 to that in 1993?
Give a very brief answer. 1.26. What is the ratio of the Value added (current US$) in Papua New Guinea in 1991 to that in 1993?
Ensure brevity in your answer.  0.72. What is the ratio of the Value added (current US$) of Thailand in 1991 to that in 1993?
Ensure brevity in your answer.  1.2. What is the ratio of the Value added (current US$) of Guinea in 1991 to that in 1994?
Provide a succinct answer. 0.81. What is the ratio of the Value added (current US$) of Italy in 1991 to that in 1994?
Make the answer very short. 1.23. What is the ratio of the Value added (current US$) of Papua New Guinea in 1991 to that in 1994?
Offer a terse response. 0.55. What is the ratio of the Value added (current US$) of Thailand in 1991 to that in 1994?
Give a very brief answer. 0.98. What is the ratio of the Value added (current US$) in Guinea in 1991 to that in 1995?
Make the answer very short. 0.8. What is the ratio of the Value added (current US$) of Italy in 1991 to that in 1995?
Provide a short and direct response. 1.15. What is the ratio of the Value added (current US$) of Papua New Guinea in 1991 to that in 1995?
Your response must be concise. 0.63. What is the ratio of the Value added (current US$) of Thailand in 1991 to that in 1995?
Offer a terse response. 0.81. What is the ratio of the Value added (current US$) of Guinea in 1991 to that in 1996?
Give a very brief answer. 0.82. What is the ratio of the Value added (current US$) in Italy in 1991 to that in 1996?
Provide a short and direct response. 1.03. What is the ratio of the Value added (current US$) of Papua New Guinea in 1991 to that in 1996?
Offer a terse response. 0.6. What is the ratio of the Value added (current US$) in Thailand in 1991 to that in 1996?
Keep it short and to the point. 0.75. What is the ratio of the Value added (current US$) in Guinea in 1992 to that in 1993?
Make the answer very short. 0.95. What is the ratio of the Value added (current US$) of Italy in 1992 to that in 1993?
Make the answer very short. 1.29. What is the ratio of the Value added (current US$) of Papua New Guinea in 1992 to that in 1993?
Provide a short and direct response. 0.78. What is the ratio of the Value added (current US$) of Thailand in 1992 to that in 1993?
Keep it short and to the point. 1.32. What is the ratio of the Value added (current US$) of Guinea in 1992 to that in 1994?
Your response must be concise. 0.8. What is the ratio of the Value added (current US$) in Italy in 1992 to that in 1994?
Give a very brief answer. 1.25. What is the ratio of the Value added (current US$) of Papua New Guinea in 1992 to that in 1994?
Give a very brief answer. 0.6. What is the ratio of the Value added (current US$) in Thailand in 1992 to that in 1994?
Ensure brevity in your answer.  1.08. What is the ratio of the Value added (current US$) in Guinea in 1992 to that in 1995?
Your response must be concise. 0.8. What is the ratio of the Value added (current US$) in Italy in 1992 to that in 1995?
Give a very brief answer. 1.18. What is the ratio of the Value added (current US$) of Papua New Guinea in 1992 to that in 1995?
Your response must be concise. 0.68. What is the ratio of the Value added (current US$) in Thailand in 1992 to that in 1995?
Keep it short and to the point. 0.89. What is the ratio of the Value added (current US$) of Guinea in 1992 to that in 1996?
Your response must be concise. 0.81. What is the ratio of the Value added (current US$) in Italy in 1992 to that in 1996?
Your answer should be compact. 1.05. What is the ratio of the Value added (current US$) of Papua New Guinea in 1992 to that in 1996?
Keep it short and to the point. 0.66. What is the ratio of the Value added (current US$) in Thailand in 1992 to that in 1996?
Ensure brevity in your answer.  0.83. What is the ratio of the Value added (current US$) in Guinea in 1993 to that in 1994?
Offer a terse response. 0.84. What is the ratio of the Value added (current US$) in Italy in 1993 to that in 1994?
Make the answer very short. 0.97. What is the ratio of the Value added (current US$) of Papua New Guinea in 1993 to that in 1994?
Provide a short and direct response. 0.77. What is the ratio of the Value added (current US$) of Thailand in 1993 to that in 1994?
Offer a terse response. 0.82. What is the ratio of the Value added (current US$) in Guinea in 1993 to that in 1995?
Offer a terse response. 0.83. What is the ratio of the Value added (current US$) in Italy in 1993 to that in 1995?
Provide a succinct answer. 0.91. What is the ratio of the Value added (current US$) in Papua New Guinea in 1993 to that in 1995?
Ensure brevity in your answer.  0.87. What is the ratio of the Value added (current US$) in Thailand in 1993 to that in 1995?
Provide a short and direct response. 0.67. What is the ratio of the Value added (current US$) of Guinea in 1993 to that in 1996?
Provide a succinct answer. 0.85. What is the ratio of the Value added (current US$) in Italy in 1993 to that in 1996?
Provide a succinct answer. 0.82. What is the ratio of the Value added (current US$) of Papua New Guinea in 1993 to that in 1996?
Offer a very short reply. 0.84. What is the ratio of the Value added (current US$) of Thailand in 1993 to that in 1996?
Offer a terse response. 0.62. What is the ratio of the Value added (current US$) of Guinea in 1994 to that in 1995?
Make the answer very short. 1. What is the ratio of the Value added (current US$) in Italy in 1994 to that in 1995?
Provide a short and direct response. 0.94. What is the ratio of the Value added (current US$) of Papua New Guinea in 1994 to that in 1995?
Your response must be concise. 1.14. What is the ratio of the Value added (current US$) in Thailand in 1994 to that in 1995?
Provide a short and direct response. 0.82. What is the ratio of the Value added (current US$) in Guinea in 1994 to that in 1996?
Offer a very short reply. 1.01. What is the ratio of the Value added (current US$) of Italy in 1994 to that in 1996?
Provide a succinct answer. 0.84. What is the ratio of the Value added (current US$) of Papua New Guinea in 1994 to that in 1996?
Provide a succinct answer. 1.09. What is the ratio of the Value added (current US$) of Thailand in 1994 to that in 1996?
Your answer should be compact. 0.76. What is the ratio of the Value added (current US$) in Guinea in 1995 to that in 1996?
Ensure brevity in your answer.  1.02. What is the ratio of the Value added (current US$) of Italy in 1995 to that in 1996?
Keep it short and to the point. 0.9. What is the ratio of the Value added (current US$) of Papua New Guinea in 1995 to that in 1996?
Offer a very short reply. 0.96. What is the ratio of the Value added (current US$) in Thailand in 1995 to that in 1996?
Ensure brevity in your answer.  0.93. What is the difference between the highest and the second highest Value added (current US$) of Guinea?
Provide a short and direct response. 1.69e+06. What is the difference between the highest and the second highest Value added (current US$) in Italy?
Offer a terse response. 7.87e+08. What is the difference between the highest and the second highest Value added (current US$) of Papua New Guinea?
Give a very brief answer. 1.49e+08. What is the difference between the highest and the second highest Value added (current US$) of Thailand?
Ensure brevity in your answer.  1.22e+09. What is the difference between the highest and the lowest Value added (current US$) of Guinea?
Your answer should be compact. 1.40e+08. What is the difference between the highest and the lowest Value added (current US$) in Italy?
Your answer should be very brief. 9.15e+09. What is the difference between the highest and the lowest Value added (current US$) of Papua New Guinea?
Keep it short and to the point. 8.48e+08. What is the difference between the highest and the lowest Value added (current US$) in Thailand?
Your answer should be very brief. 6.25e+09. 